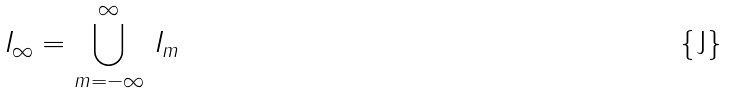Convert formula to latex. <formula><loc_0><loc_0><loc_500><loc_500>I _ { \infty } = \bigcup ^ { \infty } _ { m = - \infty } \, I _ { m }</formula> 